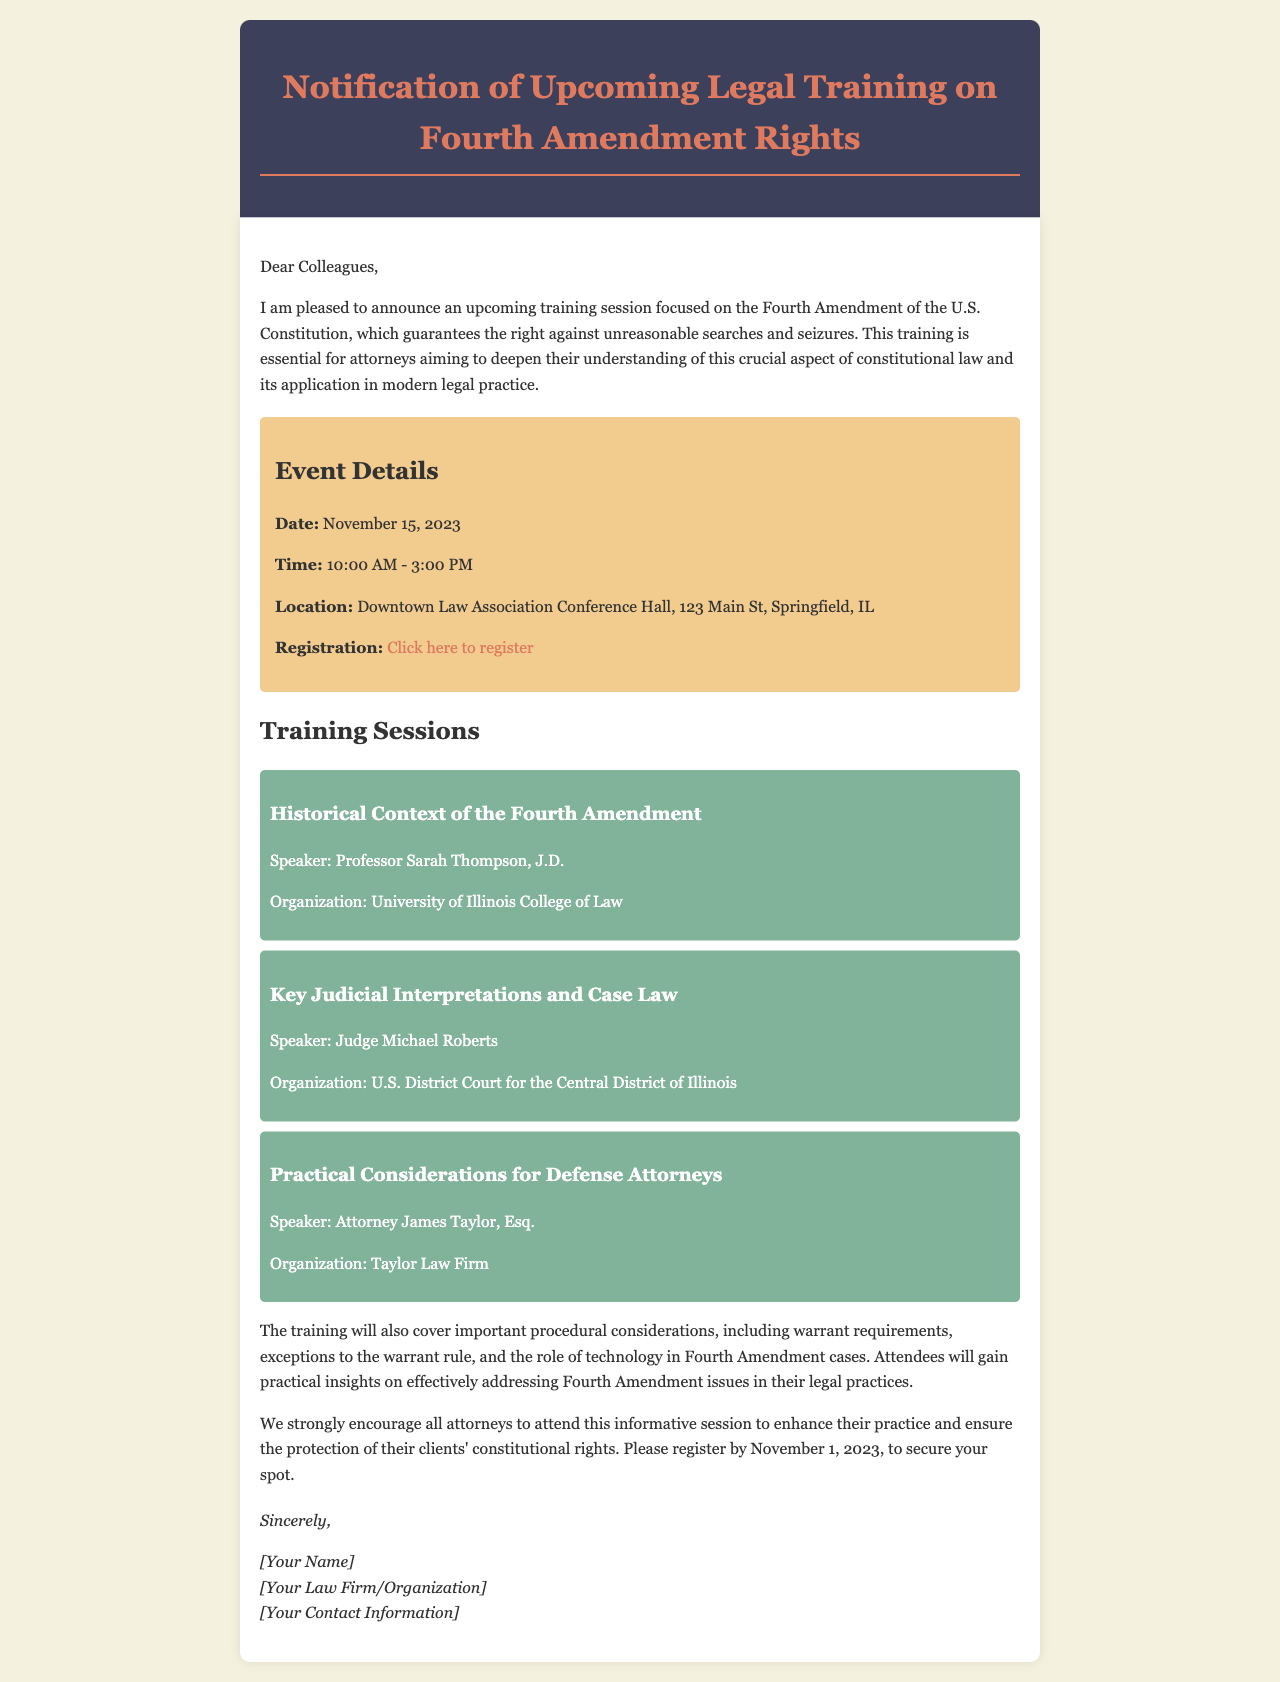What is the date of the training session? The date of the training session is explicitly stated in the document.
Answer: November 15, 2023 What are the training session's hours? The document specifies the time range for the training session.
Answer: 10:00 AM - 3:00 PM Where will the training be held? The location is clearly mentioned in the document.
Answer: Downtown Law Association Conference Hall, 123 Main St, Springfield, IL Who is the speaker for the session on Key Judicial Interpretations and Case Law? The document provides the name of the speaker for that specific session.
Answer: Judge Michael Roberts What is the last date for registration? The document indicates a deadline for registration.
Answer: November 1, 2023 Why is this training session important? The document highlights the significance of the training for attorneys.
Answer: To deepen understanding of the Fourth Amendment What will attendees learn regarding Fourth Amendment issues? The document outlines specific topics that will be covered during the training.
Answer: Practical insights on effectively addressing Fourth Amendment issues Who is the training session organized by? The document does not state an organization but implies a collective effort.
Answer: Attorneys What is the primary focus of the training session? The document specifies the main subject of the training.
Answer: Fourth Amendment rights and procedural considerations 